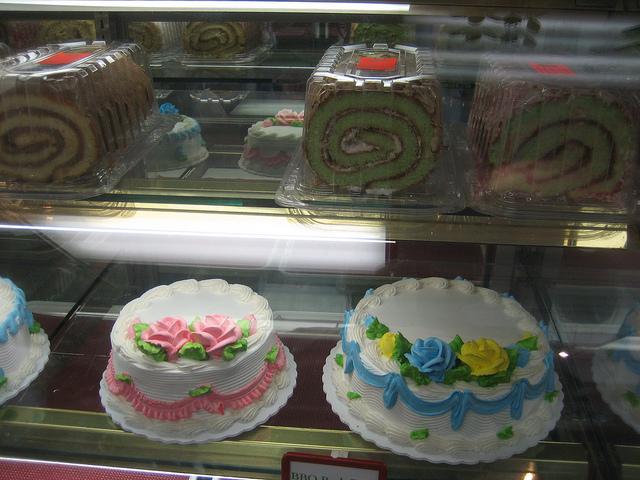Are these cake?
Concise answer only. Yes. Are there any doughnuts?
Write a very short answer. No. What decoration is on top of the cake?
Quick response, please. Flowers. 